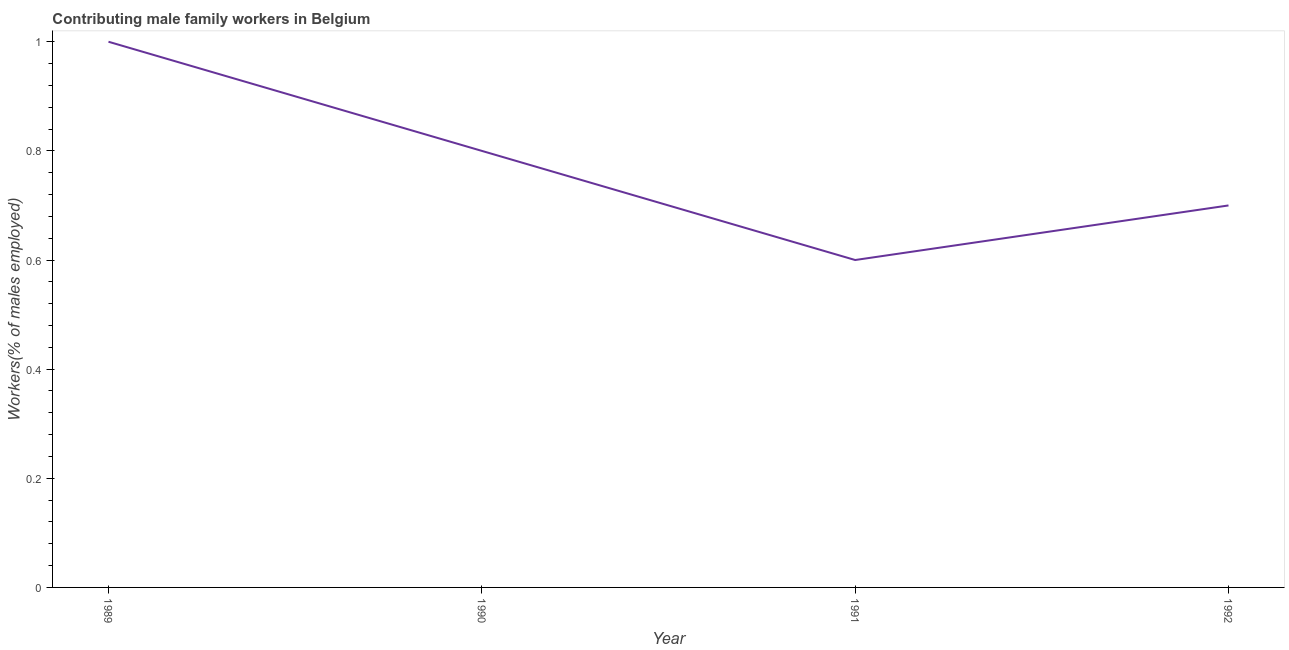What is the contributing male family workers in 1990?
Your answer should be compact. 0.8. Across all years, what is the minimum contributing male family workers?
Provide a short and direct response. 0.6. In which year was the contributing male family workers maximum?
Provide a succinct answer. 1989. What is the sum of the contributing male family workers?
Provide a succinct answer. 3.1. What is the difference between the contributing male family workers in 1990 and 1992?
Provide a succinct answer. 0.1. What is the average contributing male family workers per year?
Offer a very short reply. 0.78. What is the median contributing male family workers?
Ensure brevity in your answer.  0.75. In how many years, is the contributing male family workers greater than 0.48000000000000004 %?
Keep it short and to the point. 4. What is the ratio of the contributing male family workers in 1989 to that in 1990?
Provide a succinct answer. 1.25. What is the difference between the highest and the second highest contributing male family workers?
Give a very brief answer. 0.2. Is the sum of the contributing male family workers in 1989 and 1992 greater than the maximum contributing male family workers across all years?
Give a very brief answer. Yes. What is the difference between the highest and the lowest contributing male family workers?
Keep it short and to the point. 0.4. In how many years, is the contributing male family workers greater than the average contributing male family workers taken over all years?
Ensure brevity in your answer.  2. Does the contributing male family workers monotonically increase over the years?
Provide a succinct answer. No. How many years are there in the graph?
Make the answer very short. 4. Are the values on the major ticks of Y-axis written in scientific E-notation?
Ensure brevity in your answer.  No. Does the graph contain grids?
Give a very brief answer. No. What is the title of the graph?
Your answer should be very brief. Contributing male family workers in Belgium. What is the label or title of the X-axis?
Offer a terse response. Year. What is the label or title of the Y-axis?
Provide a succinct answer. Workers(% of males employed). What is the Workers(% of males employed) of 1990?
Offer a very short reply. 0.8. What is the Workers(% of males employed) in 1991?
Make the answer very short. 0.6. What is the Workers(% of males employed) in 1992?
Your answer should be very brief. 0.7. What is the difference between the Workers(% of males employed) in 1989 and 1992?
Give a very brief answer. 0.3. What is the difference between the Workers(% of males employed) in 1990 and 1991?
Your response must be concise. 0.2. What is the difference between the Workers(% of males employed) in 1990 and 1992?
Keep it short and to the point. 0.1. What is the difference between the Workers(% of males employed) in 1991 and 1992?
Provide a short and direct response. -0.1. What is the ratio of the Workers(% of males employed) in 1989 to that in 1990?
Give a very brief answer. 1.25. What is the ratio of the Workers(% of males employed) in 1989 to that in 1991?
Make the answer very short. 1.67. What is the ratio of the Workers(% of males employed) in 1989 to that in 1992?
Provide a short and direct response. 1.43. What is the ratio of the Workers(% of males employed) in 1990 to that in 1991?
Your response must be concise. 1.33. What is the ratio of the Workers(% of males employed) in 1990 to that in 1992?
Provide a short and direct response. 1.14. What is the ratio of the Workers(% of males employed) in 1991 to that in 1992?
Give a very brief answer. 0.86. 